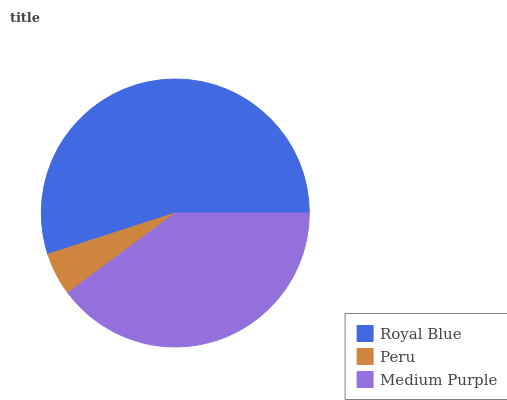Is Peru the minimum?
Answer yes or no. Yes. Is Royal Blue the maximum?
Answer yes or no. Yes. Is Medium Purple the minimum?
Answer yes or no. No. Is Medium Purple the maximum?
Answer yes or no. No. Is Medium Purple greater than Peru?
Answer yes or no. Yes. Is Peru less than Medium Purple?
Answer yes or no. Yes. Is Peru greater than Medium Purple?
Answer yes or no. No. Is Medium Purple less than Peru?
Answer yes or no. No. Is Medium Purple the high median?
Answer yes or no. Yes. Is Medium Purple the low median?
Answer yes or no. Yes. Is Peru the high median?
Answer yes or no. No. Is Peru the low median?
Answer yes or no. No. 